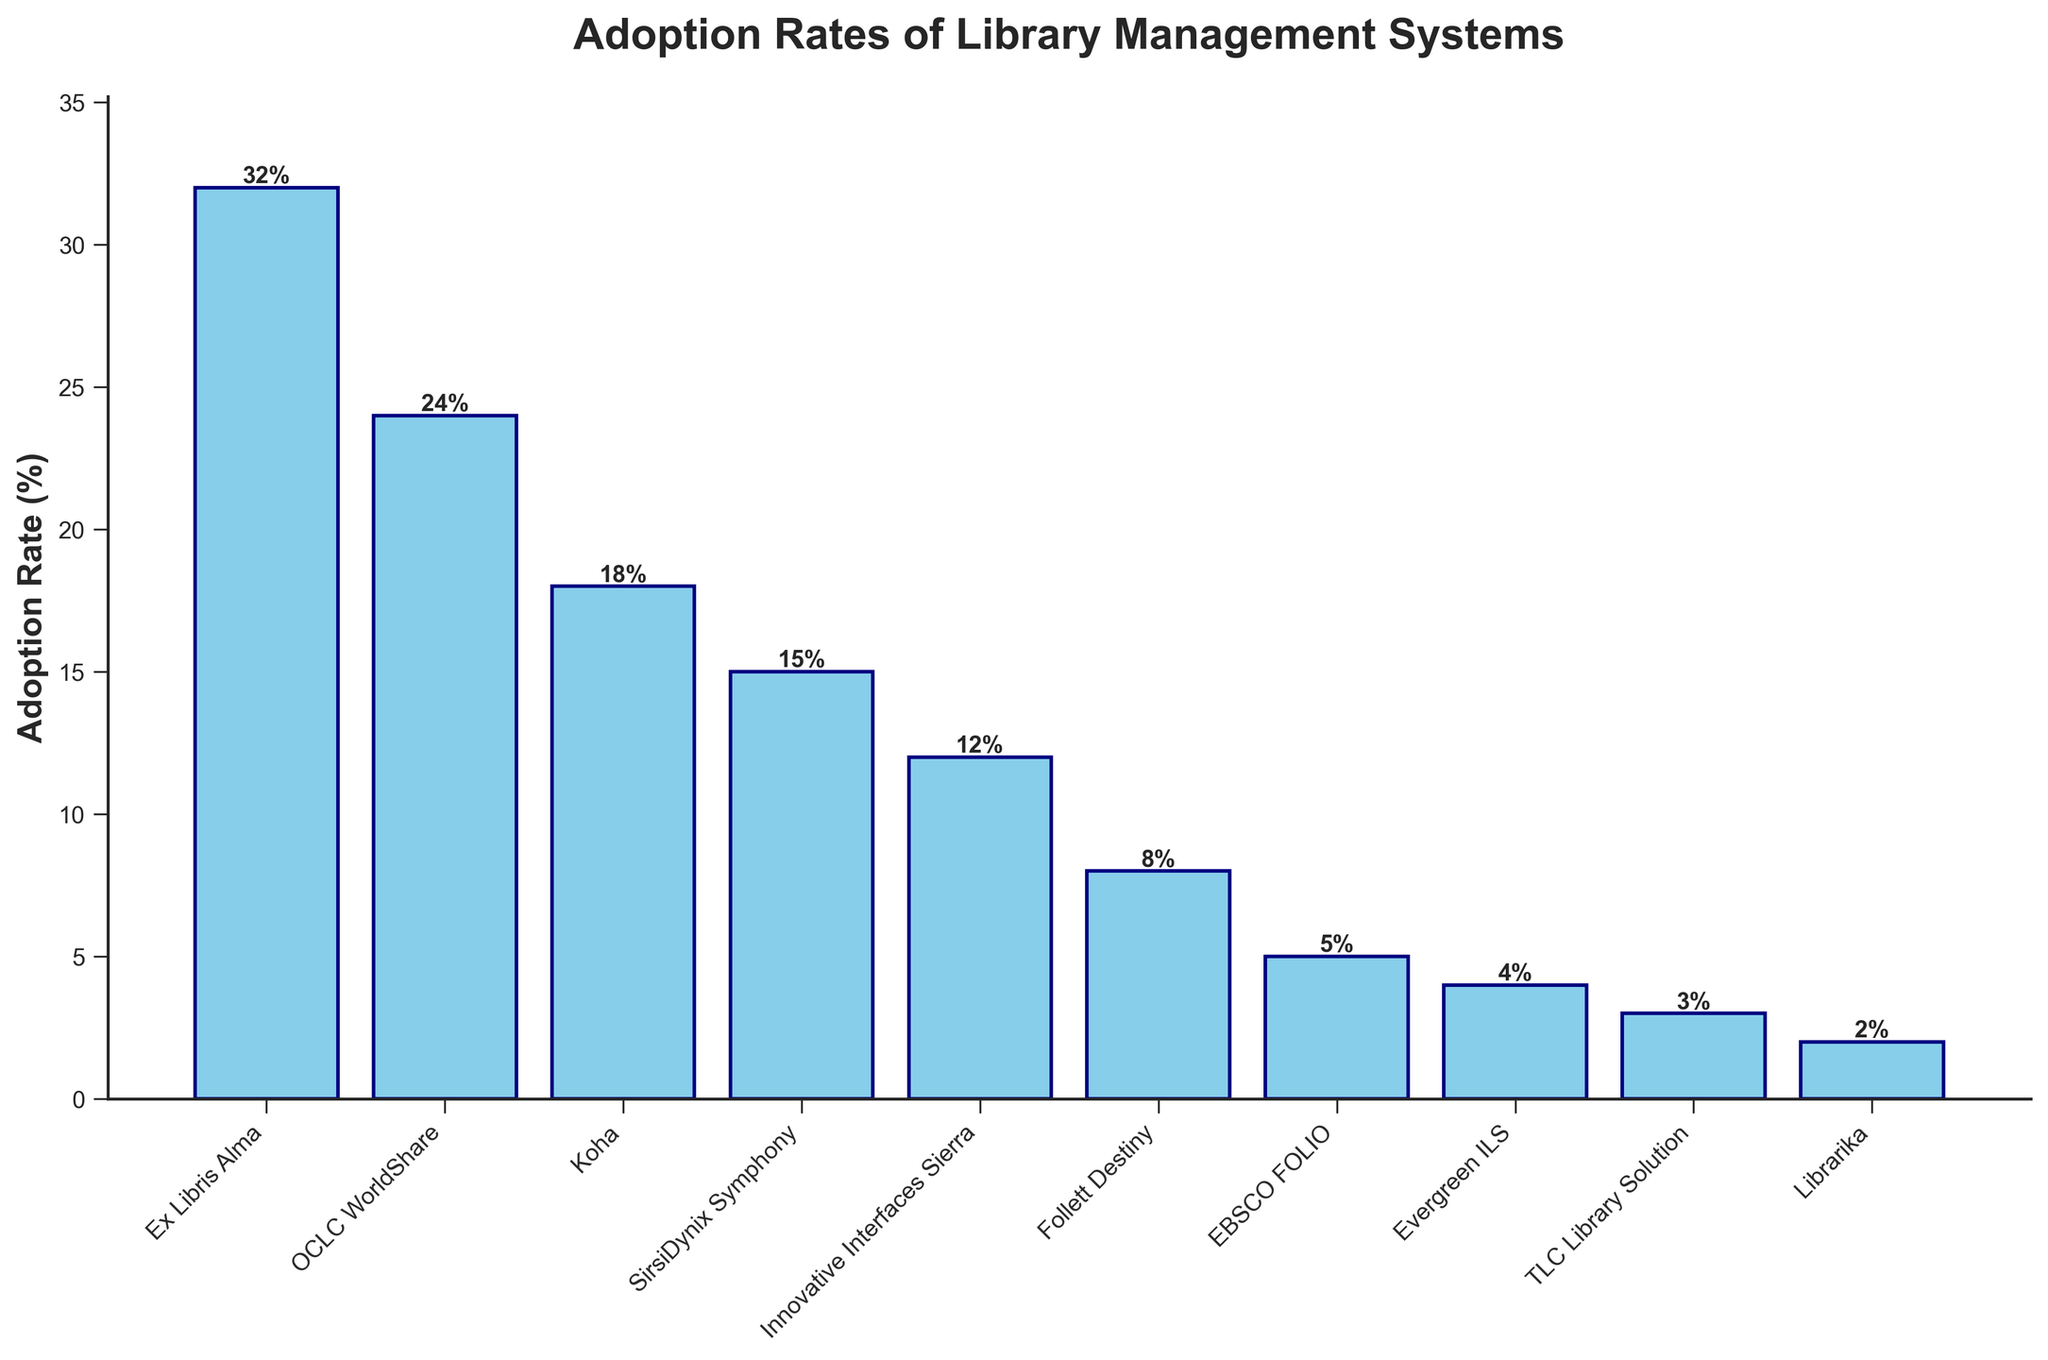How many systems have an adoption rate above 20%? Look at the bars above the 20% mark; Ex Libris Alma (32%) and OCLC WorldShare (24%) are above 20%.
Answer: 2 Which system has the lowest adoption rate? Find the shortest bar; Librarika is the shortest with 2%.
Answer: Librarika What's the difference in adoption rates between Ex Libris Alma and SirsiDynix Symphony? Ex Libris Alma has 32% and SirsiDynix Symphony has 15%. Subtract 15 from 32.
Answer: 17% Is Koha more popular than Follett Destiny? Compare the heights of the bars for Koha (18%) and Follett Destiny (8%); Koha is taller.
Answer: Yes Which system has exactly half the adoption rate of Ex Libris Alma? Ex Libris Alma has 32%, half of it is 16%. No system has exactly 16%; SirsiDynix Symphony is closest with 15%.
Answer: None exactly, closest: SirsiDynix Symphony What's the combined adoption rate of Innovative Interfaces Sierra and TLC Library Solution? Innovative Interfaces Sierra has 12% and TLC Library Solution has 3%. Sum them up: 12 + 3 = 15.
Answer: 15% Is there a gap greater than 10% between any two consecutive systems in adoption rate? Look at the differences between each consecutive system's adoption rate. The difference between Ex Libris Alma (32%) and OCLC WorldShare (24%) is 8%, so no difference exceeds 10%.
Answer: No What is the median adoption rate of the listed systems? Arrange the rates: 2%, 3%, 4%, 5%, 8%, 12%, 15%, 18%, 24%, 32%. Median is the middle value of the ordered list (for 10 items, average 5th and 6th): (8 + 12) / 2 = 10.
Answer: 10% If you combine the adoption rates of the three least adopted systems, what percentage do they account for? Least systems are Librarika (2%), TLC Library Solution (3%), and Evergreen ILS (4%). Sum: 2 + 3 + 4 = 9.
Answer: 9% 